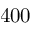<formula> <loc_0><loc_0><loc_500><loc_500>4 0 0</formula> 